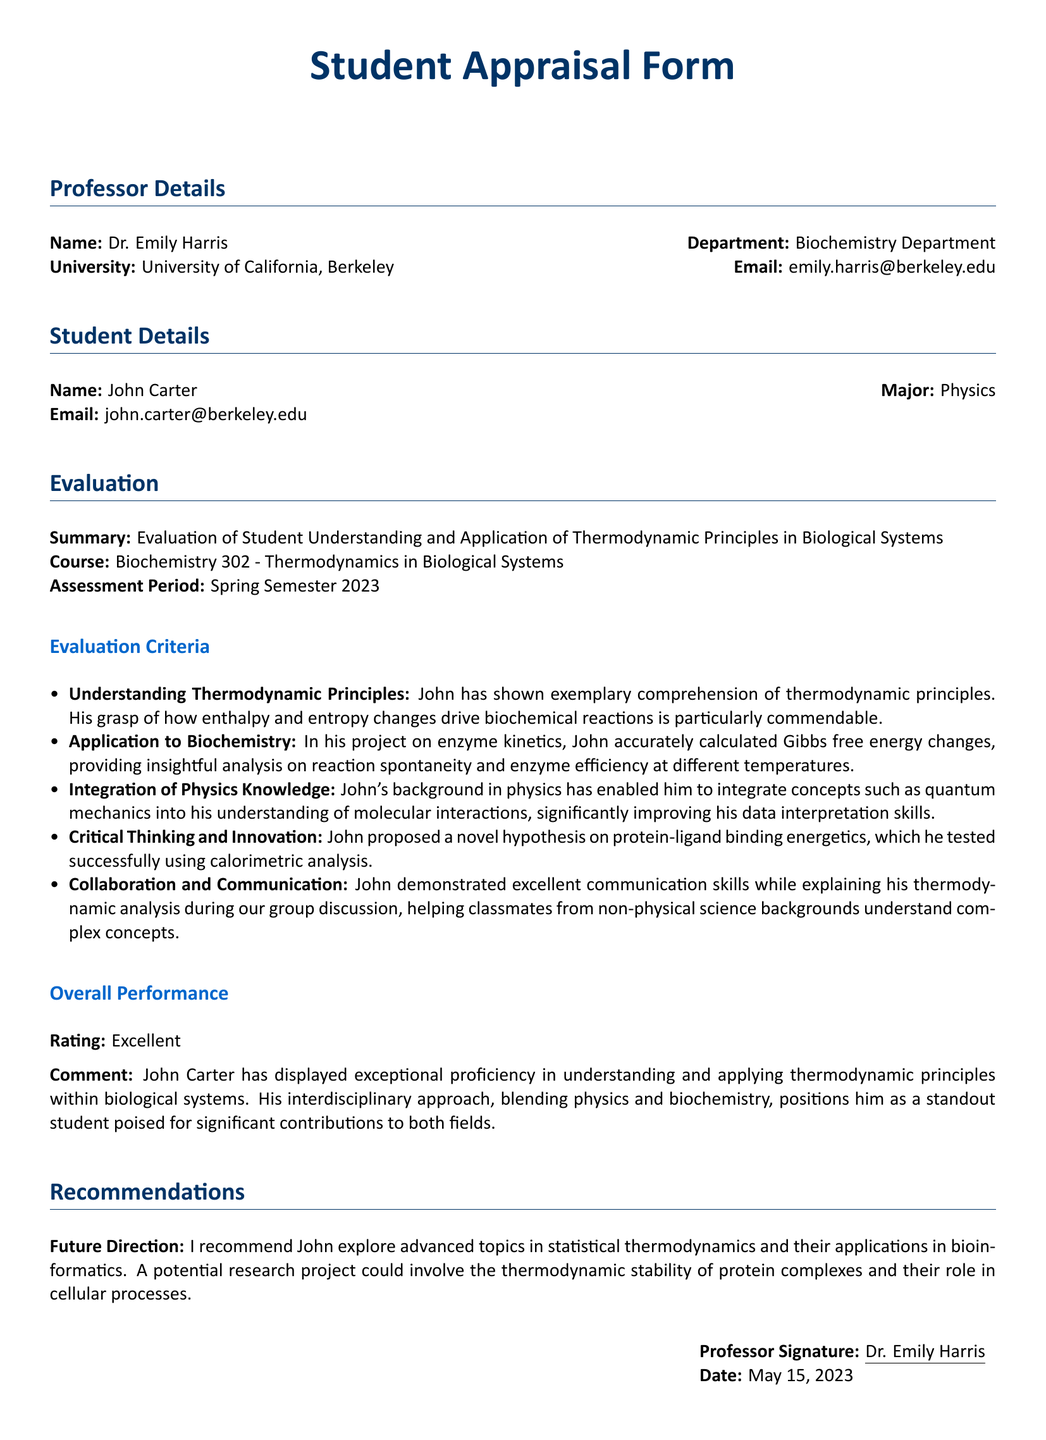What is the name of the professor? The document states the name of the professor as Dr. Emily Harris.
Answer: Dr. Emily Harris What is John's major? The document specifies that John's major is Physics.
Answer: Physics What is the assessment period? The assessment period is indicated as Spring Semester 2023 in the document.
Answer: Spring Semester 2023 What rating did John receive for his overall performance? John's overall performance is rated as Excellent in the document.
Answer: Excellent What hypothesis did John propose? The document mentions that John proposed a novel hypothesis on protein-ligand binding energetics.
Answer: protein-ligand binding energetics What specific project did John work on? The specific project John worked on is referred to as enzyme kinetics in the document.
Answer: enzyme kinetics What future direction is recommended for John? The document recommends that John explore advanced topics in statistical thermodynamics.
Answer: statistical thermodynamics Who is the signature for the appraisal form? The document indicates that the signature for the appraisal form is Dr. Emily Harris.
Answer: Dr. Emily Harris What department is Dr. Emily Harris associated with? The document indicates that Dr. Emily Harris is associated with the Biochemistry Department.
Answer: Biochemistry Department 